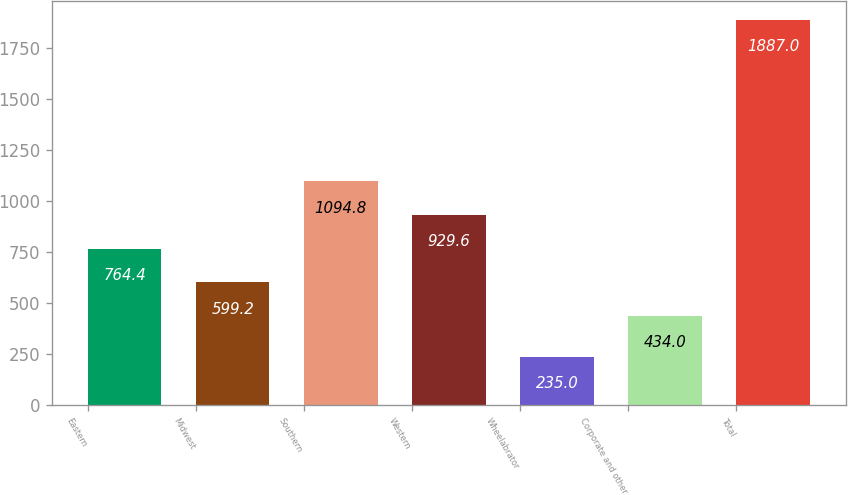<chart> <loc_0><loc_0><loc_500><loc_500><bar_chart><fcel>Eastern<fcel>Midwest<fcel>Southern<fcel>Western<fcel>Wheelabrator<fcel>Corporate and other<fcel>Total<nl><fcel>764.4<fcel>599.2<fcel>1094.8<fcel>929.6<fcel>235<fcel>434<fcel>1887<nl></chart> 